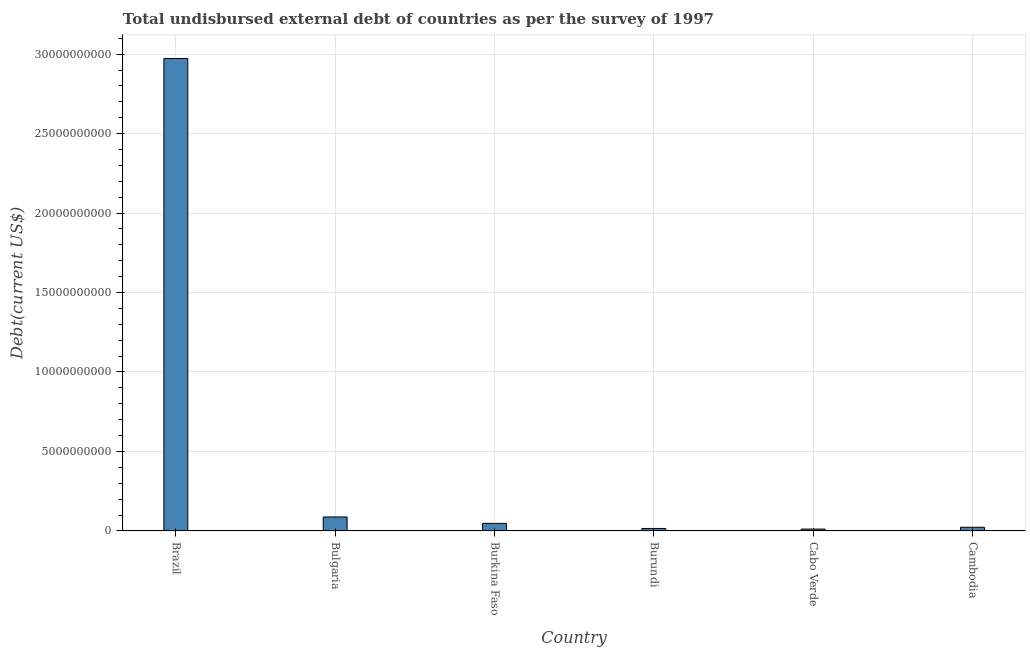Does the graph contain any zero values?
Give a very brief answer. No. Does the graph contain grids?
Keep it short and to the point. Yes. What is the title of the graph?
Your answer should be very brief. Total undisbursed external debt of countries as per the survey of 1997. What is the label or title of the X-axis?
Your answer should be very brief. Country. What is the label or title of the Y-axis?
Provide a short and direct response. Debt(current US$). What is the total debt in Brazil?
Provide a succinct answer. 2.97e+1. Across all countries, what is the maximum total debt?
Your answer should be compact. 2.97e+1. Across all countries, what is the minimum total debt?
Your response must be concise. 1.18e+08. In which country was the total debt maximum?
Ensure brevity in your answer.  Brazil. In which country was the total debt minimum?
Ensure brevity in your answer.  Cabo Verde. What is the sum of the total debt?
Keep it short and to the point. 3.16e+1. What is the difference between the total debt in Bulgaria and Burkina Faso?
Offer a very short reply. 4.04e+08. What is the average total debt per country?
Make the answer very short. 5.26e+09. What is the median total debt?
Provide a succinct answer. 3.54e+08. What is the ratio of the total debt in Burkina Faso to that in Cabo Verde?
Give a very brief answer. 4.05. Is the total debt in Cabo Verde less than that in Cambodia?
Give a very brief answer. Yes. Is the difference between the total debt in Burundi and Cabo Verde greater than the difference between any two countries?
Offer a terse response. No. What is the difference between the highest and the second highest total debt?
Make the answer very short. 2.88e+1. What is the difference between the highest and the lowest total debt?
Your response must be concise. 2.96e+1. In how many countries, is the total debt greater than the average total debt taken over all countries?
Offer a terse response. 1. How many bars are there?
Offer a very short reply. 6. Are all the bars in the graph horizontal?
Provide a short and direct response. No. How many countries are there in the graph?
Provide a short and direct response. 6. What is the difference between two consecutive major ticks on the Y-axis?
Keep it short and to the point. 5.00e+09. What is the Debt(current US$) of Brazil?
Offer a terse response. 2.97e+1. What is the Debt(current US$) in Bulgaria?
Your response must be concise. 8.80e+08. What is the Debt(current US$) of Burkina Faso?
Give a very brief answer. 4.76e+08. What is the Debt(current US$) of Burundi?
Your answer should be very brief. 1.56e+08. What is the Debt(current US$) of Cabo Verde?
Give a very brief answer. 1.18e+08. What is the Debt(current US$) in Cambodia?
Offer a terse response. 2.31e+08. What is the difference between the Debt(current US$) in Brazil and Bulgaria?
Provide a succinct answer. 2.88e+1. What is the difference between the Debt(current US$) in Brazil and Burkina Faso?
Offer a terse response. 2.92e+1. What is the difference between the Debt(current US$) in Brazil and Burundi?
Your answer should be very brief. 2.96e+1. What is the difference between the Debt(current US$) in Brazil and Cabo Verde?
Your answer should be compact. 2.96e+1. What is the difference between the Debt(current US$) in Brazil and Cambodia?
Offer a very short reply. 2.95e+1. What is the difference between the Debt(current US$) in Bulgaria and Burkina Faso?
Your answer should be compact. 4.04e+08. What is the difference between the Debt(current US$) in Bulgaria and Burundi?
Offer a terse response. 7.24e+08. What is the difference between the Debt(current US$) in Bulgaria and Cabo Verde?
Ensure brevity in your answer.  7.62e+08. What is the difference between the Debt(current US$) in Bulgaria and Cambodia?
Your answer should be compact. 6.49e+08. What is the difference between the Debt(current US$) in Burkina Faso and Burundi?
Your answer should be very brief. 3.20e+08. What is the difference between the Debt(current US$) in Burkina Faso and Cabo Verde?
Offer a very short reply. 3.59e+08. What is the difference between the Debt(current US$) in Burkina Faso and Cambodia?
Your answer should be compact. 2.45e+08. What is the difference between the Debt(current US$) in Burundi and Cabo Verde?
Your response must be concise. 3.83e+07. What is the difference between the Debt(current US$) in Burundi and Cambodia?
Make the answer very short. -7.51e+07. What is the difference between the Debt(current US$) in Cabo Verde and Cambodia?
Your response must be concise. -1.13e+08. What is the ratio of the Debt(current US$) in Brazil to that in Bulgaria?
Offer a very short reply. 33.79. What is the ratio of the Debt(current US$) in Brazil to that in Burkina Faso?
Make the answer very short. 62.43. What is the ratio of the Debt(current US$) in Brazil to that in Burundi?
Make the answer very short. 190.59. What is the ratio of the Debt(current US$) in Brazil to that in Cabo Verde?
Offer a very short reply. 252.68. What is the ratio of the Debt(current US$) in Brazil to that in Cambodia?
Offer a terse response. 128.65. What is the ratio of the Debt(current US$) in Bulgaria to that in Burkina Faso?
Your answer should be compact. 1.85. What is the ratio of the Debt(current US$) in Bulgaria to that in Burundi?
Your response must be concise. 5.64. What is the ratio of the Debt(current US$) in Bulgaria to that in Cabo Verde?
Offer a very short reply. 7.48. What is the ratio of the Debt(current US$) in Bulgaria to that in Cambodia?
Make the answer very short. 3.81. What is the ratio of the Debt(current US$) in Burkina Faso to that in Burundi?
Your response must be concise. 3.05. What is the ratio of the Debt(current US$) in Burkina Faso to that in Cabo Verde?
Provide a succinct answer. 4.05. What is the ratio of the Debt(current US$) in Burkina Faso to that in Cambodia?
Ensure brevity in your answer.  2.06. What is the ratio of the Debt(current US$) in Burundi to that in Cabo Verde?
Provide a succinct answer. 1.33. What is the ratio of the Debt(current US$) in Burundi to that in Cambodia?
Give a very brief answer. 0.68. What is the ratio of the Debt(current US$) in Cabo Verde to that in Cambodia?
Give a very brief answer. 0.51. 